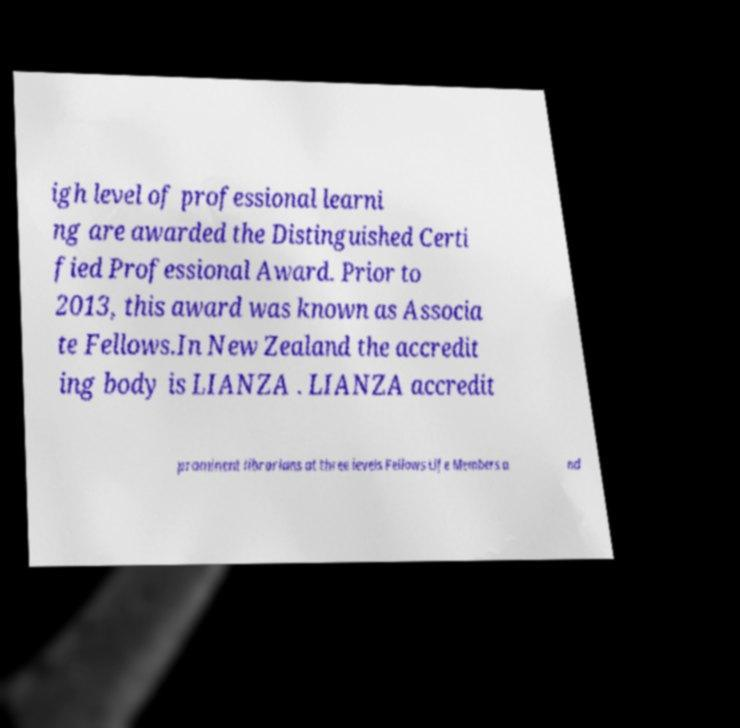Could you extract and type out the text from this image? igh level of professional learni ng are awarded the Distinguished Certi fied Professional Award. Prior to 2013, this award was known as Associa te Fellows.In New Zealand the accredit ing body is LIANZA . LIANZA accredit prominent librarians at three levels Fellows Life Members a nd 